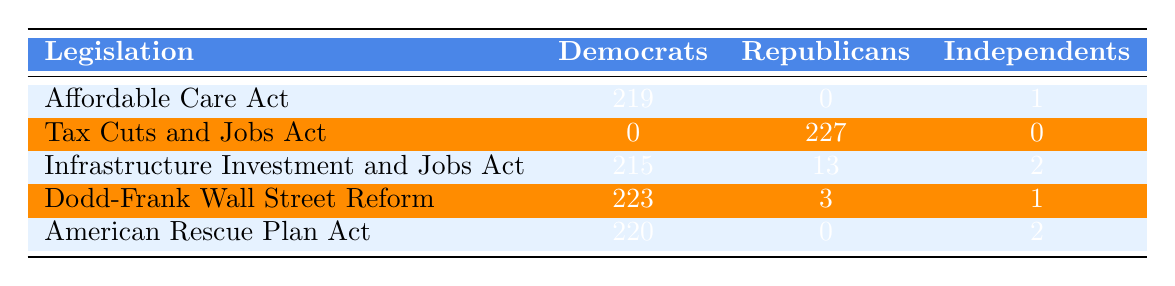What is the total number of votes by Democrats for the Affordable Care Act? The table shows that Democrats voted 219 times for the Affordable Care Act.
Answer: 219 How many votes did Republicans cast for the Tax Cuts and Jobs Act? According to the table, Republicans cast 227 votes for the Tax Cuts and Jobs Act.
Answer: 227 For which piece of legislation did Independents have the highest number of votes? By checking the Independents' column, we see that their highest vote count is 2 for the Infrastructure Investment and Jobs Act, American Rescue Plan Act, and that it is a tie.
Answer: Infrastructure Investment and Jobs Act, American Rescue Plan Act What is the sum of votes for Democrats across all pieces of legislation? To find this, we sum the Democratic votes: 219 + 0 + 215 + 223 + 220 = 877.
Answer: 877 Did any Independents vote for the Tax Cuts and Jobs Act? The table indicates that there were 0 votes by Independents for the Tax Cuts and Jobs Act.
Answer: No What is the difference in votes between Republicans and Democrats for the Infrastructure Investment and Jobs Act? Republicans voted 13 and Democrats voted 215, so the difference is 215 - 13 = 202.
Answer: 202 Which legislation had the least support from Republicans? The smallest number of Republican votes is for the Dodd-Frank Wall Street Reform, with only 3 votes.
Answer: Dodd-Frank Wall Street Reform What is the average number of votes for Independents across all pieces of legislation? Adding the votes for Independents: 1 + 0 + 2 + 1 + 2 = 6, and dividing by the 5 pieces of legislation gives us an average of 6/5 = 1.2.
Answer: 1.2 How many more votes did Democrats receive for the American Rescue Plan Act compared to Republicans? Democrats received 220 votes while Republicans received 0, thus the difference is 220 - 0 = 220.
Answer: 220 Is the number of Democratic votes for the Affordable Care Act greater than the number of Democratic votes for the Dodd-Frank Wall Street Reform? Democrats voted 219 for the Affordable Care Act and 223 for Dodd-Frank, so 219 is not greater than 223.
Answer: No 